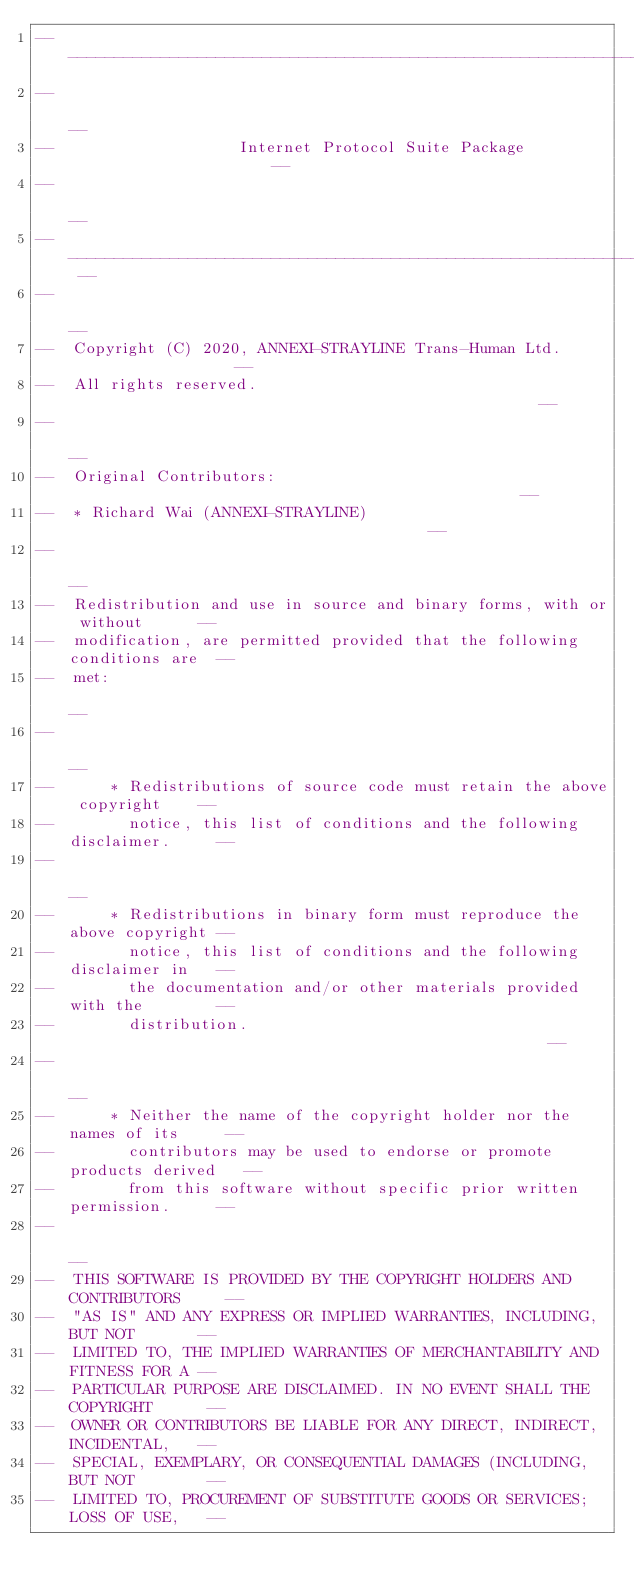Convert code to text. <code><loc_0><loc_0><loc_500><loc_500><_Ada_>------------------------------------------------------------------------------
--                                                                          --
--                    Internet Protocol Suite Package                       --
--                                                                          --
-- ------------------------------------------------------------------------ --
--                                                                          --
--  Copyright (C) 2020, ANNEXI-STRAYLINE Trans-Human Ltd.                   --
--  All rights reserved.                                                    --
--                                                                          --
--  Original Contributors:                                                  --
--  * Richard Wai (ANNEXI-STRAYLINE)                                        --
--                                                                          --
--  Redistribution and use in source and binary forms, with or without      --
--  modification, are permitted provided that the following conditions are  --
--  met:                                                                    --
--                                                                          --
--      * Redistributions of source code must retain the above copyright    --
--        notice, this list of conditions and the following disclaimer.     --
--                                                                          --
--      * Redistributions in binary form must reproduce the above copyright --
--        notice, this list of conditions and the following disclaimer in   --
--        the documentation and/or other materials provided with the        --
--        distribution.                                                     --
--                                                                          --
--      * Neither the name of the copyright holder nor the names of its     --
--        contributors may be used to endorse or promote products derived   --
--        from this software without specific prior written permission.     --
--                                                                          --
--  THIS SOFTWARE IS PROVIDED BY THE COPYRIGHT HOLDERS AND CONTRIBUTORS     --
--  "AS IS" AND ANY EXPRESS OR IMPLIED WARRANTIES, INCLUDING, BUT NOT       --
--  LIMITED TO, THE IMPLIED WARRANTIES OF MERCHANTABILITY AND FITNESS FOR A --
--  PARTICULAR PURPOSE ARE DISCLAIMED. IN NO EVENT SHALL THE COPYRIGHT      --
--  OWNER OR CONTRIBUTORS BE LIABLE FOR ANY DIRECT, INDIRECT, INCIDENTAL,   --
--  SPECIAL, EXEMPLARY, OR CONSEQUENTIAL DAMAGES (INCLUDING, BUT NOT        --
--  LIMITED TO, PROCUREMENT OF SUBSTITUTE GOODS OR SERVICES; LOSS OF USE,   --</code> 